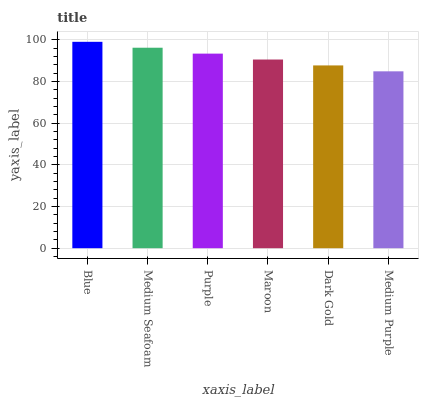Is Medium Purple the minimum?
Answer yes or no. Yes. Is Blue the maximum?
Answer yes or no. Yes. Is Medium Seafoam the minimum?
Answer yes or no. No. Is Medium Seafoam the maximum?
Answer yes or no. No. Is Blue greater than Medium Seafoam?
Answer yes or no. Yes. Is Medium Seafoam less than Blue?
Answer yes or no. Yes. Is Medium Seafoam greater than Blue?
Answer yes or no. No. Is Blue less than Medium Seafoam?
Answer yes or no. No. Is Purple the high median?
Answer yes or no. Yes. Is Maroon the low median?
Answer yes or no. Yes. Is Maroon the high median?
Answer yes or no. No. Is Blue the low median?
Answer yes or no. No. 